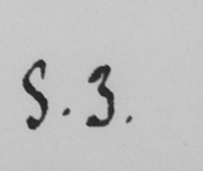Can you read and transcribe this handwriting? S . 3 . 